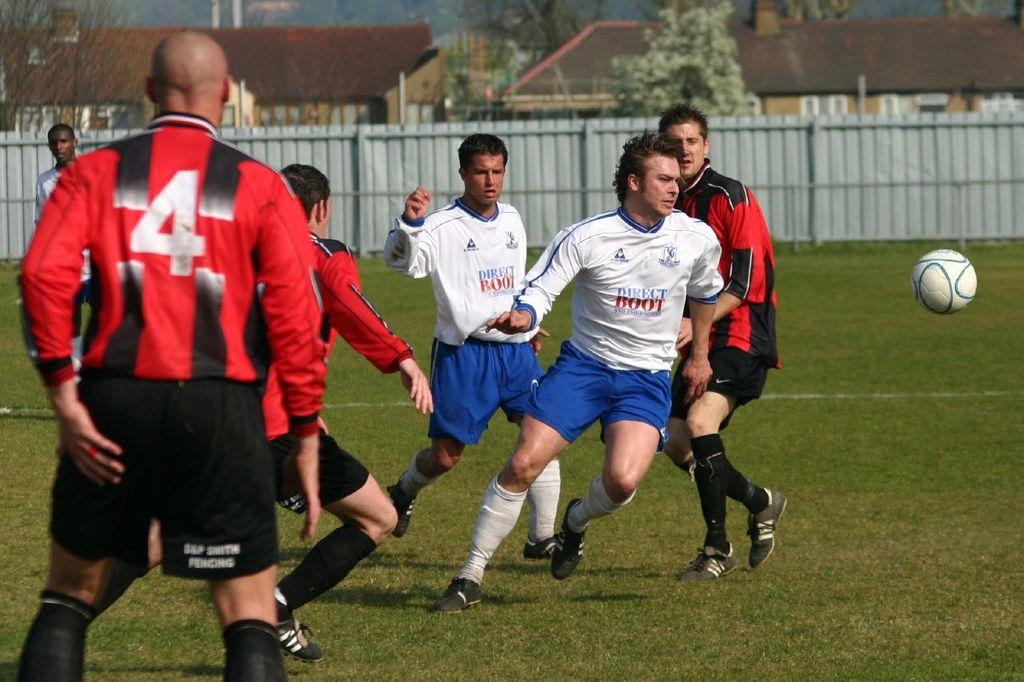<image>
Give a short and clear explanation of the subsequent image. Two teams are playing soccer and one has Direct Boot on their jerseys. 